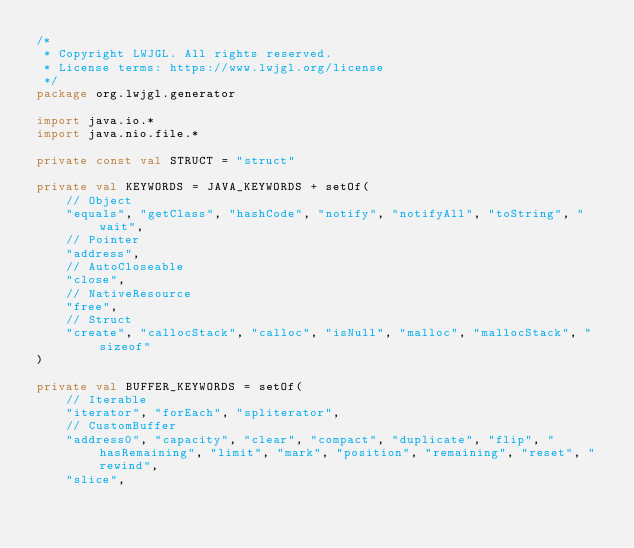<code> <loc_0><loc_0><loc_500><loc_500><_Kotlin_>/*
 * Copyright LWJGL. All rights reserved.
 * License terms: https://www.lwjgl.org/license
 */
package org.lwjgl.generator

import java.io.*
import java.nio.file.*

private const val STRUCT = "struct"

private val KEYWORDS = JAVA_KEYWORDS + setOf(
    // Object
    "equals", "getClass", "hashCode", "notify", "notifyAll", "toString", "wait",
    // Pointer
    "address",
    // AutoCloseable
    "close",
    // NativeResource
    "free",
    // Struct
    "create", "callocStack", "calloc", "isNull", "malloc", "mallocStack", "sizeof"
)

private val BUFFER_KEYWORDS = setOf(
    // Iterable
    "iterator", "forEach", "spliterator",
    // CustomBuffer
    "address0", "capacity", "clear", "compact", "duplicate", "flip", "hasRemaining", "limit", "mark", "position", "remaining", "reset", "rewind",
    "slice",</code> 